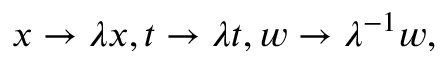<formula> <loc_0><loc_0><loc_500><loc_500>x \to \lambda x , t \to \lambda t , w \to \lambda ^ { - 1 } w ,</formula> 